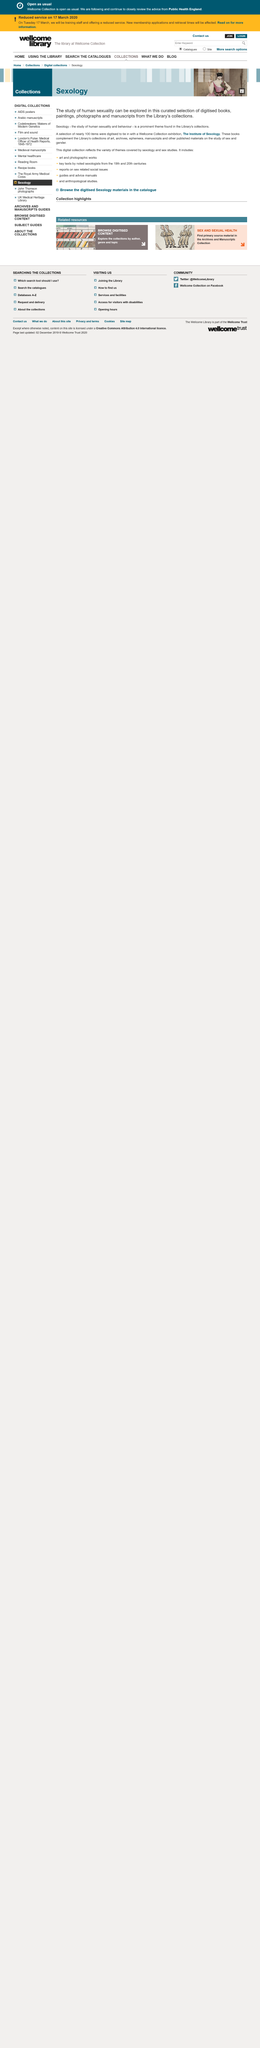Identify some key points in this picture. Sexology is the scientific study of human sexuality and behavior, encompassing both the biological and social aspects of sexuality. The study of human sexuality can be explored through a curated selection of digitized books, paintings, photographs, and manuscripts from the Institute of Sexology's library, providing a comprehensive insight into the subject. The library's collection features a prevalent theme of sexology, which is a prominent field of study that focuses on the scientific and sociocultural aspects of human sexuality. 